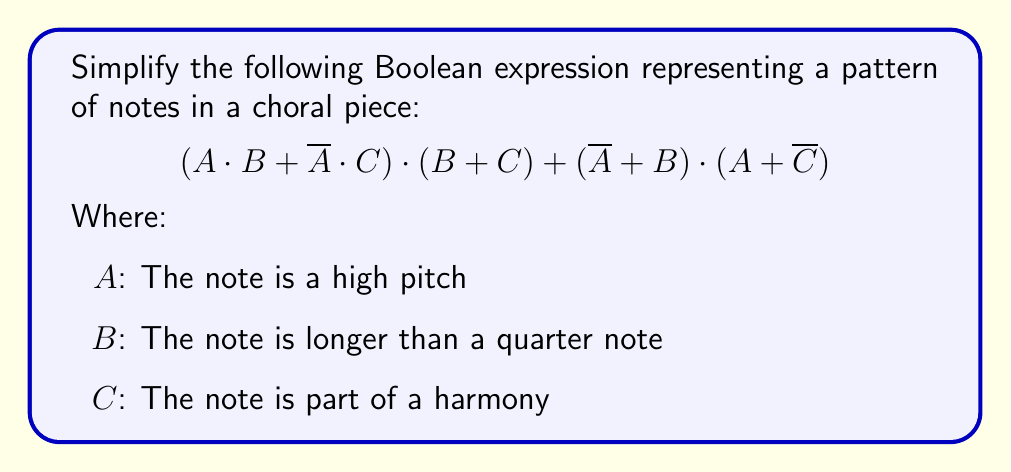Provide a solution to this math problem. Let's simplify this expression step by step:

1) First, let's apply the distributive law to $(A \cdot B + \overline{A} \cdot C) \cdot (B + C)$:
   $$(A \cdot B \cdot B + A \cdot B \cdot C + \overline{A} \cdot C \cdot B + \overline{A} \cdot C \cdot C)$$

2) Simplify using the idempotent law $(X \cdot X = X)$:
   $$(A \cdot B + A \cdot B \cdot C + \overline{A} \cdot C \cdot B + \overline{A} \cdot C)$$

3) Now, let's simplify $(\overline{A} + B) \cdot (A + \overline{C})$:
   $$(\overline{A} \cdot A + \overline{A} \cdot \overline{C} + B \cdot A + B \cdot \overline{C})$$

4) Simplify using the complement law $(\overline{A} \cdot A = 0)$:
   $$(\overline{A} \cdot \overline{C} + B \cdot A + B \cdot \overline{C})$$

5) Now our expression is:
   $$(A \cdot B + A \cdot B \cdot C + \overline{A} \cdot C \cdot B + \overline{A} \cdot C) + (\overline{A} \cdot \overline{C} + B \cdot A + B \cdot \overline{C})$$

6) Rearrange terms:
   $$(A \cdot B + A \cdot B \cdot C + B \cdot A) + (\overline{A} \cdot C \cdot B + \overline{A} \cdot C + \overline{A} \cdot \overline{C}) + B \cdot \overline{C}$$

7) Simplify using absorption law $(X + X \cdot Y = X)$:
   $$(A \cdot B) + (\overline{A} \cdot C + \overline{A} \cdot \overline{C}) + B \cdot \overline{C}$$

8) Apply the distributive law to $\overline{A} \cdot C + \overline{A} \cdot \overline{C}$:
   $$(A \cdot B) + \overline{A} \cdot (C + \overline{C}) + B \cdot \overline{C}$$

9) Simplify using the complement law $(C + \overline{C} = 1)$:
   $$(A \cdot B) + \overline{A} + B \cdot \overline{C}$$

This is our final simplified expression.
Answer: $A \cdot B + \overline{A} + B \cdot \overline{C}$ 